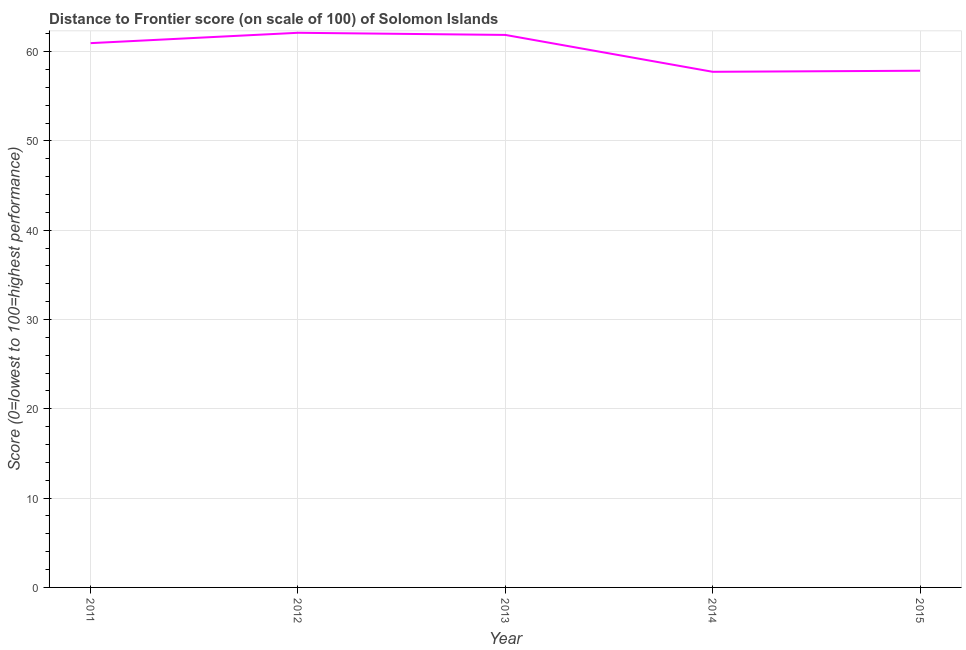What is the distance to frontier score in 2015?
Provide a succinct answer. 57.86. Across all years, what is the maximum distance to frontier score?
Provide a succinct answer. 62.11. Across all years, what is the minimum distance to frontier score?
Keep it short and to the point. 57.74. In which year was the distance to frontier score minimum?
Provide a short and direct response. 2014. What is the sum of the distance to frontier score?
Your response must be concise. 300.53. What is the difference between the distance to frontier score in 2012 and 2015?
Your response must be concise. 4.25. What is the average distance to frontier score per year?
Offer a terse response. 60.11. What is the median distance to frontier score?
Give a very brief answer. 60.95. In how many years, is the distance to frontier score greater than 44 ?
Make the answer very short. 5. Do a majority of the years between 2013 and 2014 (inclusive) have distance to frontier score greater than 24 ?
Your answer should be compact. Yes. What is the ratio of the distance to frontier score in 2011 to that in 2012?
Your response must be concise. 0.98. Is the distance to frontier score in 2011 less than that in 2013?
Your response must be concise. Yes. Is the difference between the distance to frontier score in 2011 and 2014 greater than the difference between any two years?
Give a very brief answer. No. What is the difference between the highest and the second highest distance to frontier score?
Offer a very short reply. 0.24. What is the difference between the highest and the lowest distance to frontier score?
Make the answer very short. 4.37. In how many years, is the distance to frontier score greater than the average distance to frontier score taken over all years?
Your answer should be compact. 3. Does the distance to frontier score monotonically increase over the years?
Provide a short and direct response. No. How many years are there in the graph?
Provide a succinct answer. 5. What is the difference between two consecutive major ticks on the Y-axis?
Your answer should be compact. 10. Are the values on the major ticks of Y-axis written in scientific E-notation?
Provide a succinct answer. No. What is the title of the graph?
Ensure brevity in your answer.  Distance to Frontier score (on scale of 100) of Solomon Islands. What is the label or title of the X-axis?
Keep it short and to the point. Year. What is the label or title of the Y-axis?
Keep it short and to the point. Score (0=lowest to 100=highest performance). What is the Score (0=lowest to 100=highest performance) of 2011?
Your answer should be very brief. 60.95. What is the Score (0=lowest to 100=highest performance) of 2012?
Offer a very short reply. 62.11. What is the Score (0=lowest to 100=highest performance) in 2013?
Ensure brevity in your answer.  61.87. What is the Score (0=lowest to 100=highest performance) in 2014?
Provide a short and direct response. 57.74. What is the Score (0=lowest to 100=highest performance) in 2015?
Provide a short and direct response. 57.86. What is the difference between the Score (0=lowest to 100=highest performance) in 2011 and 2012?
Ensure brevity in your answer.  -1.16. What is the difference between the Score (0=lowest to 100=highest performance) in 2011 and 2013?
Ensure brevity in your answer.  -0.92. What is the difference between the Score (0=lowest to 100=highest performance) in 2011 and 2014?
Your response must be concise. 3.21. What is the difference between the Score (0=lowest to 100=highest performance) in 2011 and 2015?
Your response must be concise. 3.09. What is the difference between the Score (0=lowest to 100=highest performance) in 2012 and 2013?
Your response must be concise. 0.24. What is the difference between the Score (0=lowest to 100=highest performance) in 2012 and 2014?
Offer a very short reply. 4.37. What is the difference between the Score (0=lowest to 100=highest performance) in 2012 and 2015?
Offer a very short reply. 4.25. What is the difference between the Score (0=lowest to 100=highest performance) in 2013 and 2014?
Make the answer very short. 4.13. What is the difference between the Score (0=lowest to 100=highest performance) in 2013 and 2015?
Offer a very short reply. 4.01. What is the difference between the Score (0=lowest to 100=highest performance) in 2014 and 2015?
Your answer should be compact. -0.12. What is the ratio of the Score (0=lowest to 100=highest performance) in 2011 to that in 2012?
Your answer should be compact. 0.98. What is the ratio of the Score (0=lowest to 100=highest performance) in 2011 to that in 2014?
Keep it short and to the point. 1.06. What is the ratio of the Score (0=lowest to 100=highest performance) in 2011 to that in 2015?
Give a very brief answer. 1.05. What is the ratio of the Score (0=lowest to 100=highest performance) in 2012 to that in 2013?
Keep it short and to the point. 1. What is the ratio of the Score (0=lowest to 100=highest performance) in 2012 to that in 2014?
Offer a very short reply. 1.08. What is the ratio of the Score (0=lowest to 100=highest performance) in 2012 to that in 2015?
Give a very brief answer. 1.07. What is the ratio of the Score (0=lowest to 100=highest performance) in 2013 to that in 2014?
Your answer should be compact. 1.07. What is the ratio of the Score (0=lowest to 100=highest performance) in 2013 to that in 2015?
Provide a succinct answer. 1.07. What is the ratio of the Score (0=lowest to 100=highest performance) in 2014 to that in 2015?
Offer a very short reply. 1. 